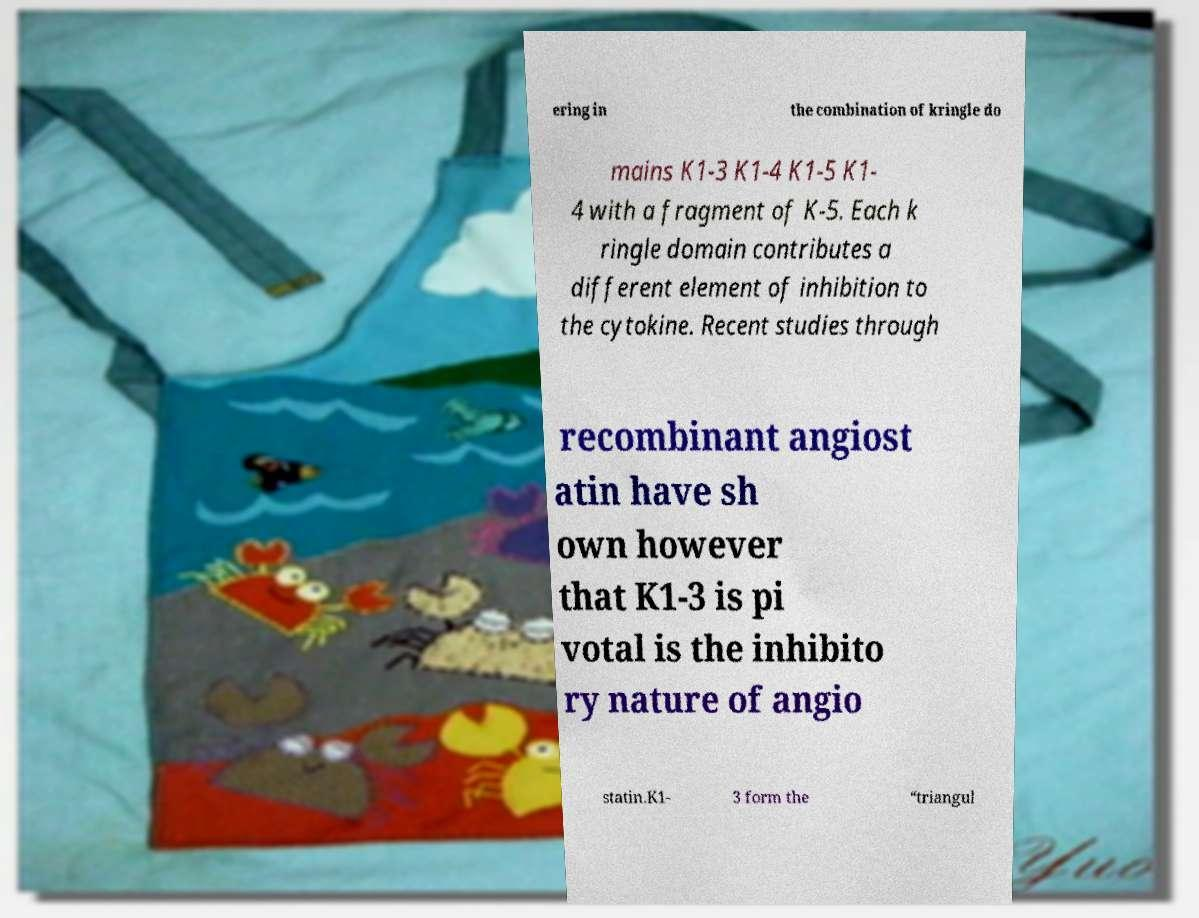What messages or text are displayed in this image? I need them in a readable, typed format. ering in the combination of kringle do mains K1-3 K1-4 K1-5 K1- 4 with a fragment of K-5. Each k ringle domain contributes a different element of inhibition to the cytokine. Recent studies through recombinant angiost atin have sh own however that K1-3 is pi votal is the inhibito ry nature of angio statin.K1- 3 form the “triangul 